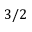Convert formula to latex. <formula><loc_0><loc_0><loc_500><loc_500>3 / 2</formula> 